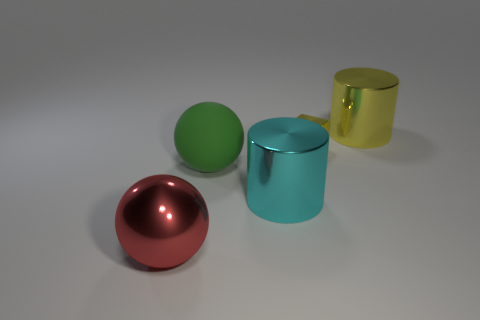Add 3 large red objects. How many objects exist? 8 Subtract all cubes. How many objects are left? 4 Subtract 0 blue cubes. How many objects are left? 5 Subtract all big green matte spheres. Subtract all yellow rubber blocks. How many objects are left? 4 Add 2 large cyan shiny cylinders. How many large cyan shiny cylinders are left? 3 Add 4 tiny yellow things. How many tiny yellow things exist? 5 